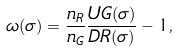<formula> <loc_0><loc_0><loc_500><loc_500>\omega ( \sigma ) = \frac { n _ { R } } { n _ { G } } \frac { U G ( \sigma ) } { D R ( \sigma ) } - 1 ,</formula> 